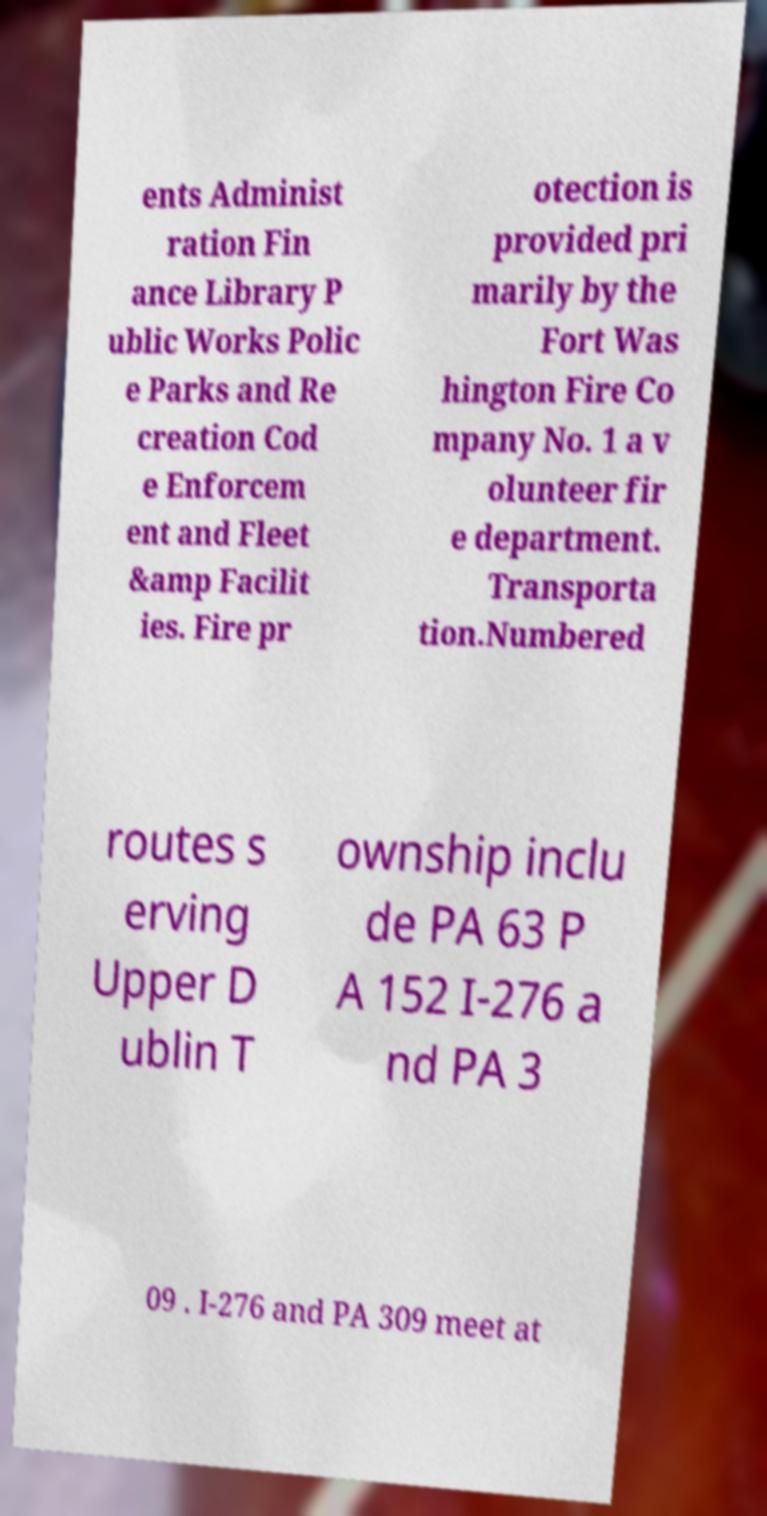Could you assist in decoding the text presented in this image and type it out clearly? ents Administ ration Fin ance Library P ublic Works Polic e Parks and Re creation Cod e Enforcem ent and Fleet &amp Facilit ies. Fire pr otection is provided pri marily by the Fort Was hington Fire Co mpany No. 1 a v olunteer fir e department. Transporta tion.Numbered routes s erving Upper D ublin T ownship inclu de PA 63 P A 152 I-276 a nd PA 3 09 . I-276 and PA 309 meet at 